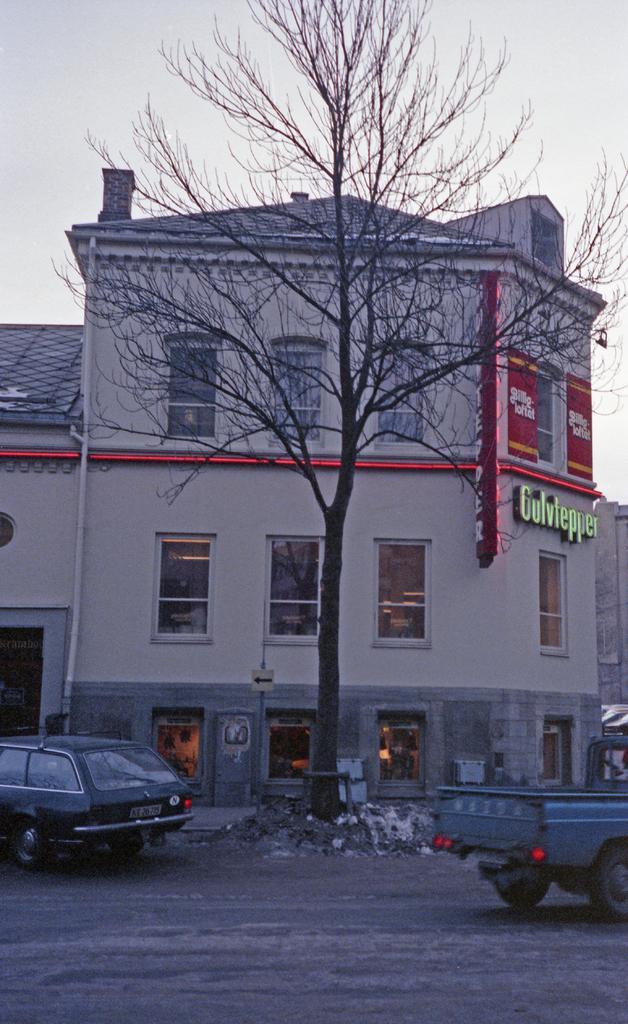Can you describe this image briefly? This is an outside view. At the bottom, I can see two vehicles on the road. In the middle of the image there is a tree. In the background there is a building. At the top of the image I can see the sky. 